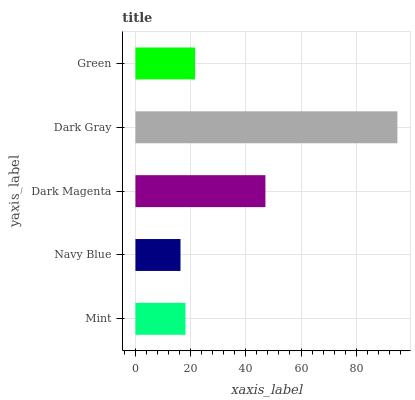Is Navy Blue the minimum?
Answer yes or no. Yes. Is Dark Gray the maximum?
Answer yes or no. Yes. Is Dark Magenta the minimum?
Answer yes or no. No. Is Dark Magenta the maximum?
Answer yes or no. No. Is Dark Magenta greater than Navy Blue?
Answer yes or no. Yes. Is Navy Blue less than Dark Magenta?
Answer yes or no. Yes. Is Navy Blue greater than Dark Magenta?
Answer yes or no. No. Is Dark Magenta less than Navy Blue?
Answer yes or no. No. Is Green the high median?
Answer yes or no. Yes. Is Green the low median?
Answer yes or no. Yes. Is Navy Blue the high median?
Answer yes or no. No. Is Dark Magenta the low median?
Answer yes or no. No. 